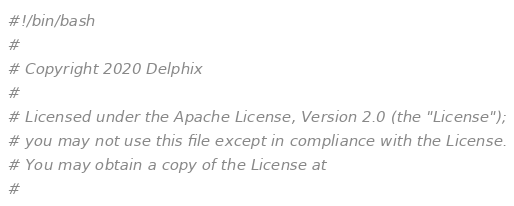<code> <loc_0><loc_0><loc_500><loc_500><_Bash_>#!/bin/bash
#
# Copyright 2020 Delphix
#
# Licensed under the Apache License, Version 2.0 (the "License");
# you may not use this file except in compliance with the License.
# You may obtain a copy of the License at
#</code> 